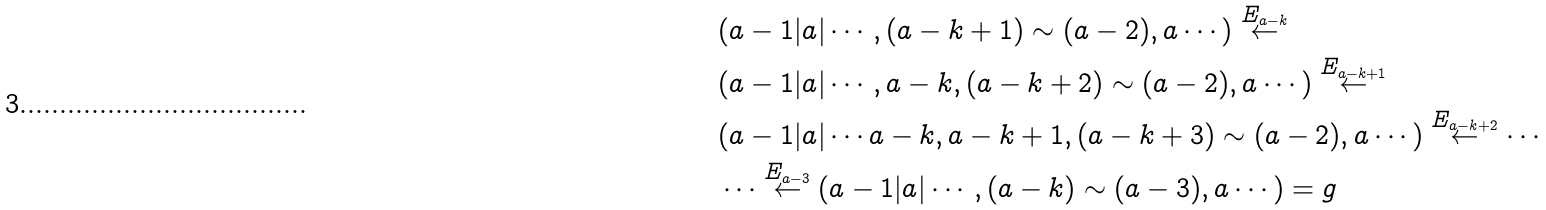<formula> <loc_0><loc_0><loc_500><loc_500>& ( a - 1 | a | \cdots , ( a - k + 1 ) \sim ( a - 2 ) , a \cdots ) \stackrel { E _ { a - k } } { \leftarrow } \\ & ( a - 1 | a | \cdots , a - k , ( a - k + 2 ) \sim ( a - 2 ) , a \cdots ) \stackrel { E _ { a - k + 1 } } { \leftarrow } \\ & ( a - 1 | a | \cdots a - k , a - k + 1 , ( a - k + 3 ) \sim ( a - 2 ) , a \cdots ) \stackrel { E _ { a - k + 2 } } { \leftarrow } \cdots \\ & \cdots \stackrel { E _ { a - 3 } } { \leftarrow } ( a - 1 | a | \cdots , ( a - k ) \sim ( a - 3 ) , a \cdots ) = g</formula> 